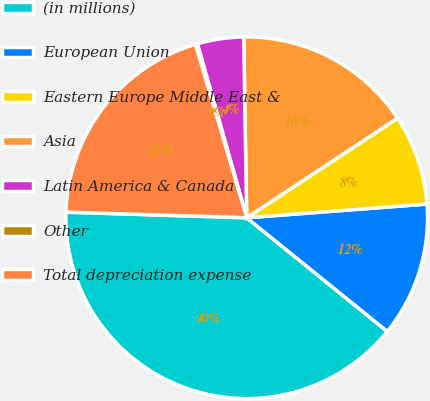<chart> <loc_0><loc_0><loc_500><loc_500><pie_chart><fcel>(in millions)<fcel>European Union<fcel>Eastern Europe Middle East &<fcel>Asia<fcel>Latin America & Canada<fcel>Other<fcel>Total depreciation expense<nl><fcel>39.68%<fcel>12.03%<fcel>8.08%<fcel>15.98%<fcel>4.13%<fcel>0.18%<fcel>19.93%<nl></chart> 